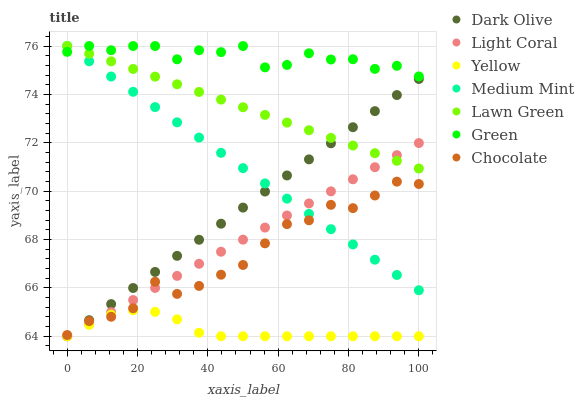Does Yellow have the minimum area under the curve?
Answer yes or no. Yes. Does Green have the maximum area under the curve?
Answer yes or no. Yes. Does Lawn Green have the minimum area under the curve?
Answer yes or no. No. Does Lawn Green have the maximum area under the curve?
Answer yes or no. No. Is Dark Olive the smoothest?
Answer yes or no. Yes. Is Green the roughest?
Answer yes or no. Yes. Is Lawn Green the smoothest?
Answer yes or no. No. Is Lawn Green the roughest?
Answer yes or no. No. Does Dark Olive have the lowest value?
Answer yes or no. Yes. Does Lawn Green have the lowest value?
Answer yes or no. No. Does Green have the highest value?
Answer yes or no. Yes. Does Dark Olive have the highest value?
Answer yes or no. No. Is Yellow less than Green?
Answer yes or no. Yes. Is Green greater than Yellow?
Answer yes or no. Yes. Does Yellow intersect Light Coral?
Answer yes or no. Yes. Is Yellow less than Light Coral?
Answer yes or no. No. Is Yellow greater than Light Coral?
Answer yes or no. No. Does Yellow intersect Green?
Answer yes or no. No. 